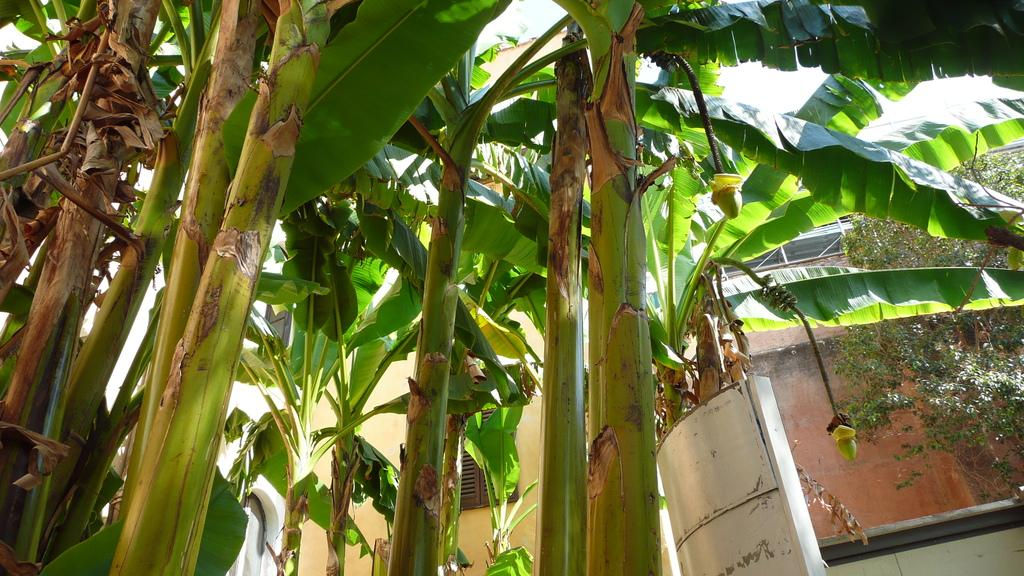What type of living organisms can be seen in the image? Plants can be seen in the image. What type of structure is visible in the image? There is a house in the image. What type of spark can be seen coming from the roof of the house in the image? There is no spark visible on the roof of the house in the image. In what type of wilderness setting is the house located in the image? The image does not provide enough information to determine the type of wilderness setting, if any, in which the house is located. 